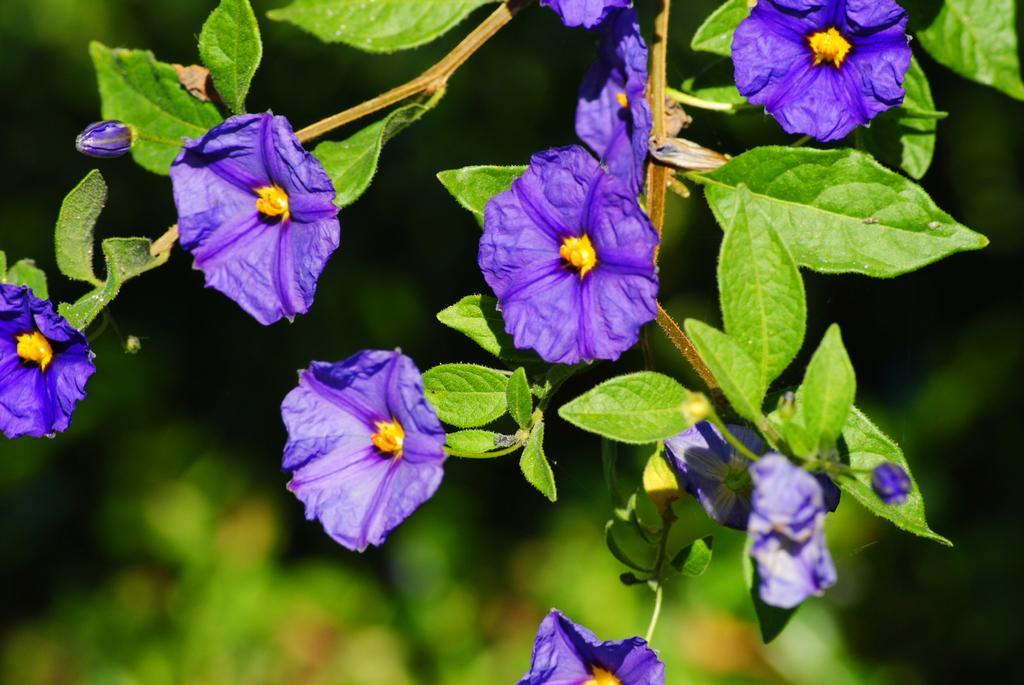Please provide a concise description of this image. In the image we can see some flowers and trees. Background of the image image is blur. 